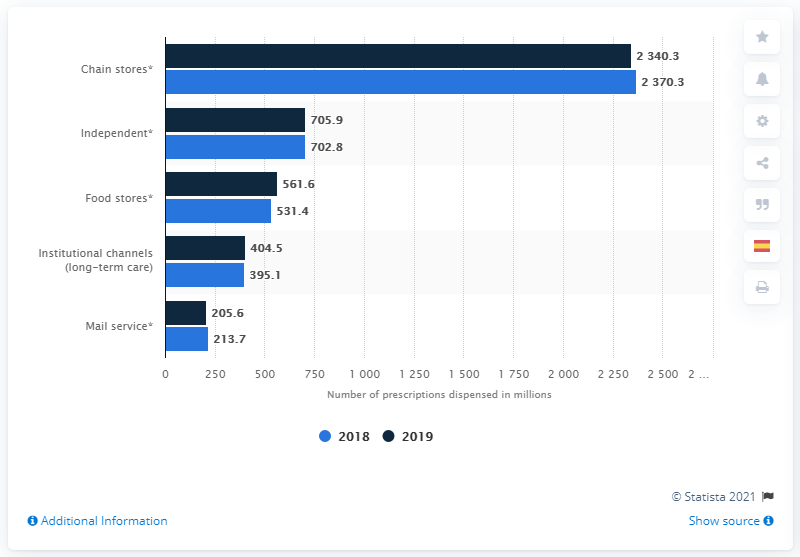Highlight a few significant elements in this photo. In 2019, a total of 2,340.3 prescriptions were distributed through a chain store retail channel. The highest channel distribution by number of dispensed prescriptions in the U.S. between 2018 and 2019 was among chain stores, which accounted for the greatest portion of prescriptions dispensed. In the United States in 2018, chain stores had the highest channel distribution by the number of dispensed prescriptions. 